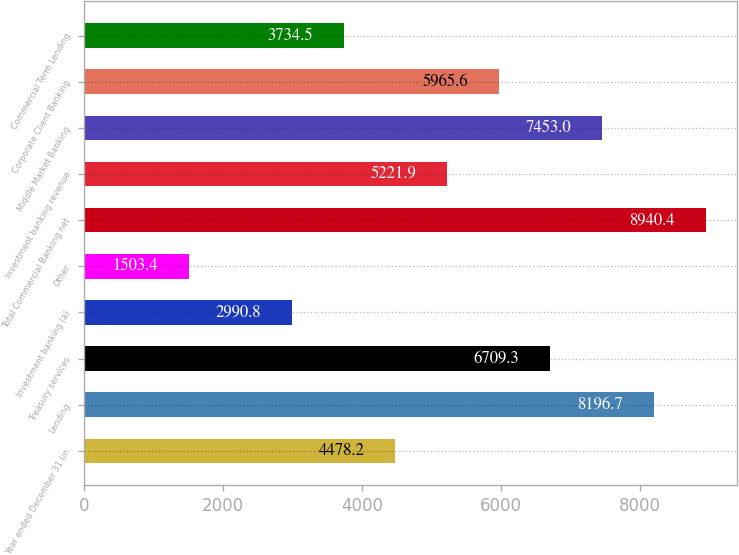Convert chart to OTSL. <chart><loc_0><loc_0><loc_500><loc_500><bar_chart><fcel>Year ended December 31 (in<fcel>Lending<fcel>Treasury services<fcel>Investment banking (a)<fcel>Other<fcel>Total Commercial Banking net<fcel>Investment banking revenue<fcel>Middle Market Banking<fcel>Corporate Client Banking<fcel>Commercial Term Lending<nl><fcel>4478.2<fcel>8196.7<fcel>6709.3<fcel>2990.8<fcel>1503.4<fcel>8940.4<fcel>5221.9<fcel>7453<fcel>5965.6<fcel>3734.5<nl></chart> 